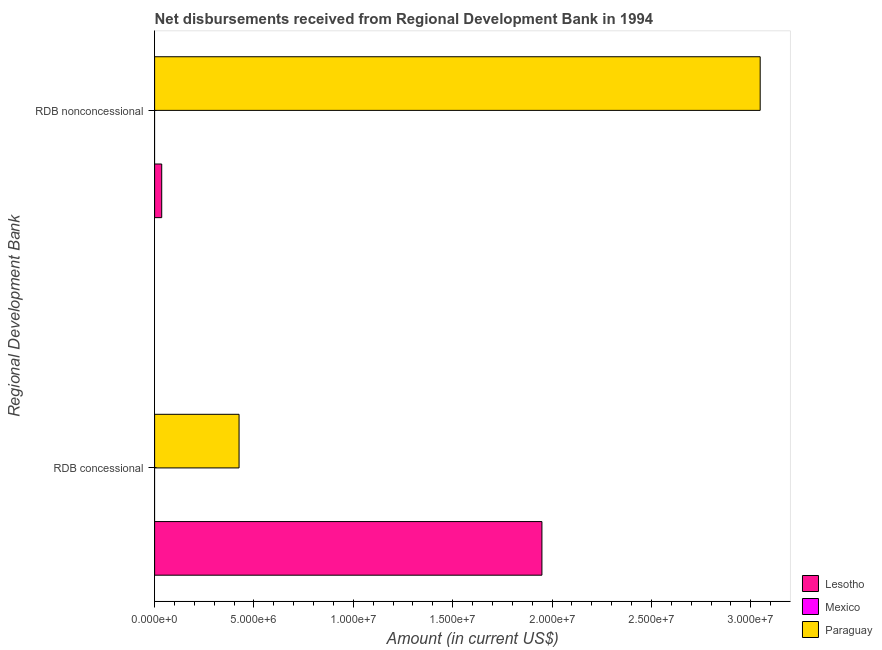How many groups of bars are there?
Your answer should be compact. 2. What is the label of the 2nd group of bars from the top?
Give a very brief answer. RDB concessional. What is the net non concessional disbursements from rdb in Lesotho?
Make the answer very short. 3.58e+05. Across all countries, what is the maximum net concessional disbursements from rdb?
Your answer should be compact. 1.95e+07. In which country was the net non concessional disbursements from rdb maximum?
Give a very brief answer. Paraguay. What is the total net concessional disbursements from rdb in the graph?
Give a very brief answer. 2.37e+07. What is the difference between the net non concessional disbursements from rdb in Lesotho and that in Paraguay?
Ensure brevity in your answer.  -3.01e+07. What is the difference between the net concessional disbursements from rdb in Paraguay and the net non concessional disbursements from rdb in Lesotho?
Your answer should be compact. 3.89e+06. What is the average net non concessional disbursements from rdb per country?
Keep it short and to the point. 1.03e+07. What is the difference between the net non concessional disbursements from rdb and net concessional disbursements from rdb in Paraguay?
Ensure brevity in your answer.  2.62e+07. How many bars are there?
Your answer should be very brief. 4. What is the difference between two consecutive major ticks on the X-axis?
Your answer should be very brief. 5.00e+06. Where does the legend appear in the graph?
Keep it short and to the point. Bottom right. How many legend labels are there?
Offer a terse response. 3. How are the legend labels stacked?
Ensure brevity in your answer.  Vertical. What is the title of the graph?
Offer a terse response. Net disbursements received from Regional Development Bank in 1994. What is the label or title of the Y-axis?
Your answer should be very brief. Regional Development Bank. What is the Amount (in current US$) in Lesotho in RDB concessional?
Offer a very short reply. 1.95e+07. What is the Amount (in current US$) of Paraguay in RDB concessional?
Your response must be concise. 4.25e+06. What is the Amount (in current US$) in Lesotho in RDB nonconcessional?
Your response must be concise. 3.58e+05. What is the Amount (in current US$) of Mexico in RDB nonconcessional?
Keep it short and to the point. 0. What is the Amount (in current US$) in Paraguay in RDB nonconcessional?
Your answer should be compact. 3.05e+07. Across all Regional Development Bank, what is the maximum Amount (in current US$) in Lesotho?
Your response must be concise. 1.95e+07. Across all Regional Development Bank, what is the maximum Amount (in current US$) of Paraguay?
Give a very brief answer. 3.05e+07. Across all Regional Development Bank, what is the minimum Amount (in current US$) of Lesotho?
Provide a succinct answer. 3.58e+05. Across all Regional Development Bank, what is the minimum Amount (in current US$) of Paraguay?
Ensure brevity in your answer.  4.25e+06. What is the total Amount (in current US$) of Lesotho in the graph?
Provide a succinct answer. 1.98e+07. What is the total Amount (in current US$) of Paraguay in the graph?
Your answer should be very brief. 3.47e+07. What is the difference between the Amount (in current US$) in Lesotho in RDB concessional and that in RDB nonconcessional?
Make the answer very short. 1.91e+07. What is the difference between the Amount (in current US$) of Paraguay in RDB concessional and that in RDB nonconcessional?
Offer a terse response. -2.62e+07. What is the difference between the Amount (in current US$) of Lesotho in RDB concessional and the Amount (in current US$) of Paraguay in RDB nonconcessional?
Provide a short and direct response. -1.10e+07. What is the average Amount (in current US$) of Lesotho per Regional Development Bank?
Your response must be concise. 9.92e+06. What is the average Amount (in current US$) in Paraguay per Regional Development Bank?
Keep it short and to the point. 1.74e+07. What is the difference between the Amount (in current US$) in Lesotho and Amount (in current US$) in Paraguay in RDB concessional?
Make the answer very short. 1.52e+07. What is the difference between the Amount (in current US$) of Lesotho and Amount (in current US$) of Paraguay in RDB nonconcessional?
Offer a very short reply. -3.01e+07. What is the ratio of the Amount (in current US$) of Lesotho in RDB concessional to that in RDB nonconcessional?
Your answer should be compact. 54.44. What is the ratio of the Amount (in current US$) in Paraguay in RDB concessional to that in RDB nonconcessional?
Your response must be concise. 0.14. What is the difference between the highest and the second highest Amount (in current US$) in Lesotho?
Ensure brevity in your answer.  1.91e+07. What is the difference between the highest and the second highest Amount (in current US$) in Paraguay?
Keep it short and to the point. 2.62e+07. What is the difference between the highest and the lowest Amount (in current US$) in Lesotho?
Keep it short and to the point. 1.91e+07. What is the difference between the highest and the lowest Amount (in current US$) in Paraguay?
Give a very brief answer. 2.62e+07. 